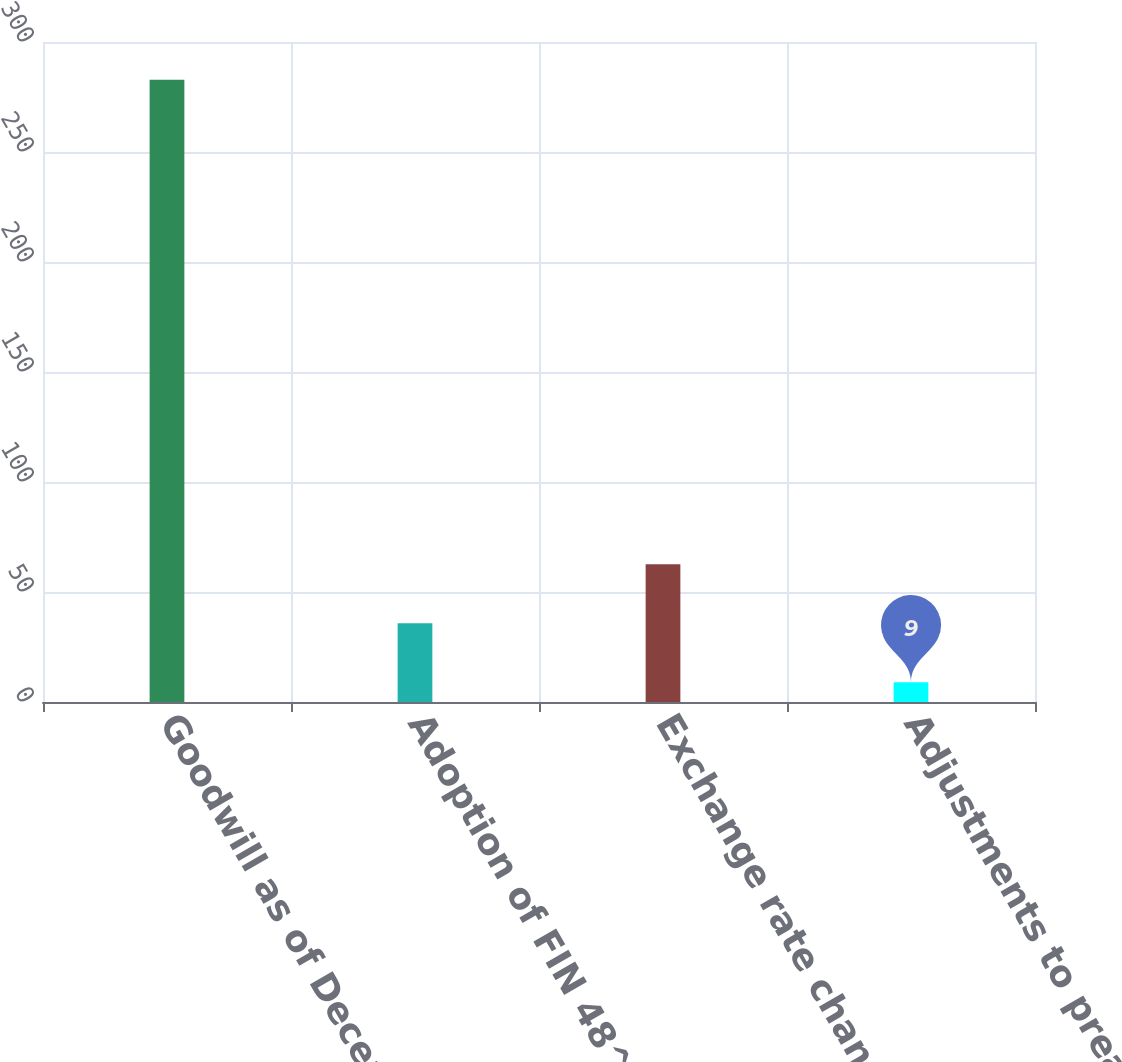<chart> <loc_0><loc_0><loc_500><loc_500><bar_chart><fcel>Goodwill as of December 31<fcel>Adoption of FIN 48^(1)<fcel>Exchange rate changes<fcel>Adjustments to preacquisition<nl><fcel>282.8<fcel>35.8<fcel>62.6<fcel>9<nl></chart> 